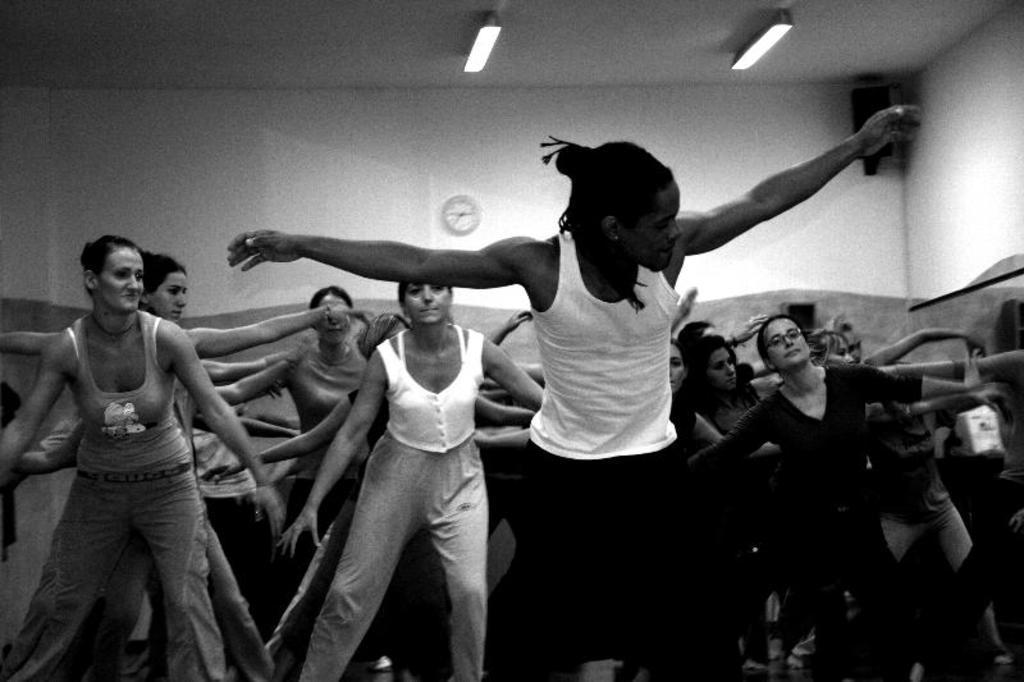Please provide a concise description of this image. This picture describes about group of people, at the top of the image we can find few lights, clock and a speaker, it is a black and white photography. 